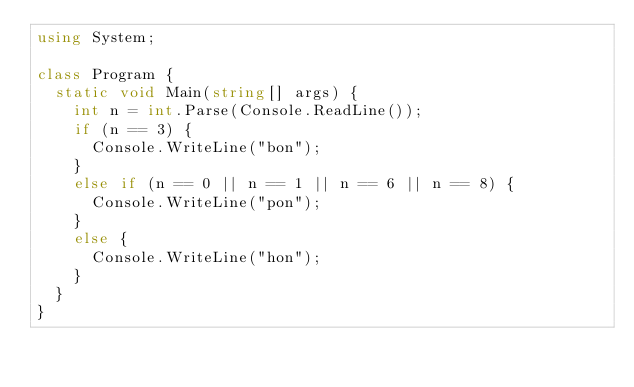<code> <loc_0><loc_0><loc_500><loc_500><_C#_>using System;

class Program {
  static void Main(string[] args) {
    int n = int.Parse(Console.ReadLine());
    if (n == 3) {
      Console.WriteLine("bon");
    }
    else if (n == 0 || n == 1 || n == 6 || n == 8) {
      Console.WriteLine("pon");
    }
    else {
      Console.WriteLine("hon");
    }
  }
}</code> 